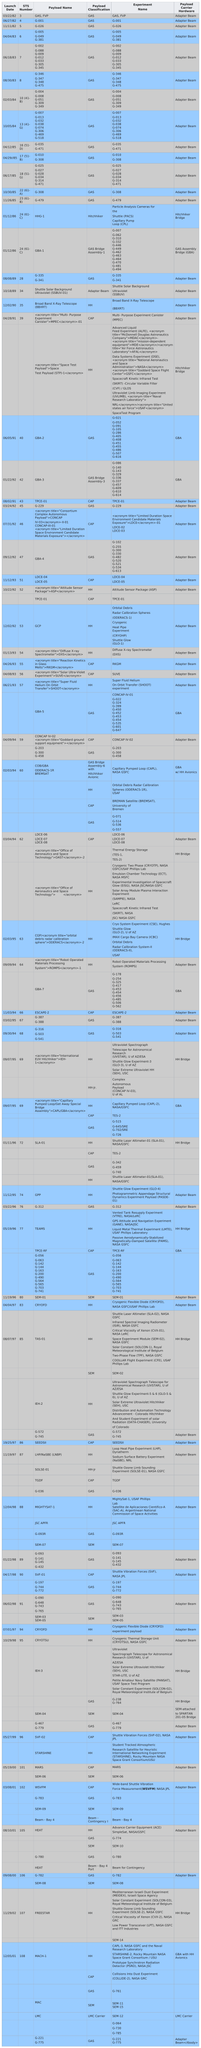Highlight a few significant elements in this photo. There are 108 sts in total. The question "which STS number comes before 4? 3..." is asking if there is a specific STS (Space Technology System) number that is before 4. The G-221 G-775, Adapter Beam is the last experiment name and payload carrier hardware. In 1996, the Shuttle Laser Altimeter-01 (SLA-01) experiment was conducted by NASA/GSFC, which involved the use of a laser altimeter to measure the altitude of the Space Shuttle during its ascent into orbit. The payload classification 'gas' is listed consecutively 13 times, starting from the top. 